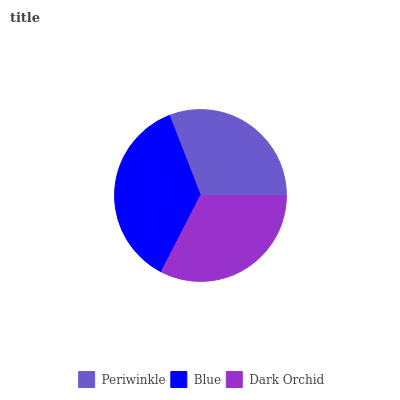Is Periwinkle the minimum?
Answer yes or no. Yes. Is Blue the maximum?
Answer yes or no. Yes. Is Dark Orchid the minimum?
Answer yes or no. No. Is Dark Orchid the maximum?
Answer yes or no. No. Is Blue greater than Dark Orchid?
Answer yes or no. Yes. Is Dark Orchid less than Blue?
Answer yes or no. Yes. Is Dark Orchid greater than Blue?
Answer yes or no. No. Is Blue less than Dark Orchid?
Answer yes or no. No. Is Dark Orchid the high median?
Answer yes or no. Yes. Is Dark Orchid the low median?
Answer yes or no. Yes. Is Periwinkle the high median?
Answer yes or no. No. Is Blue the low median?
Answer yes or no. No. 